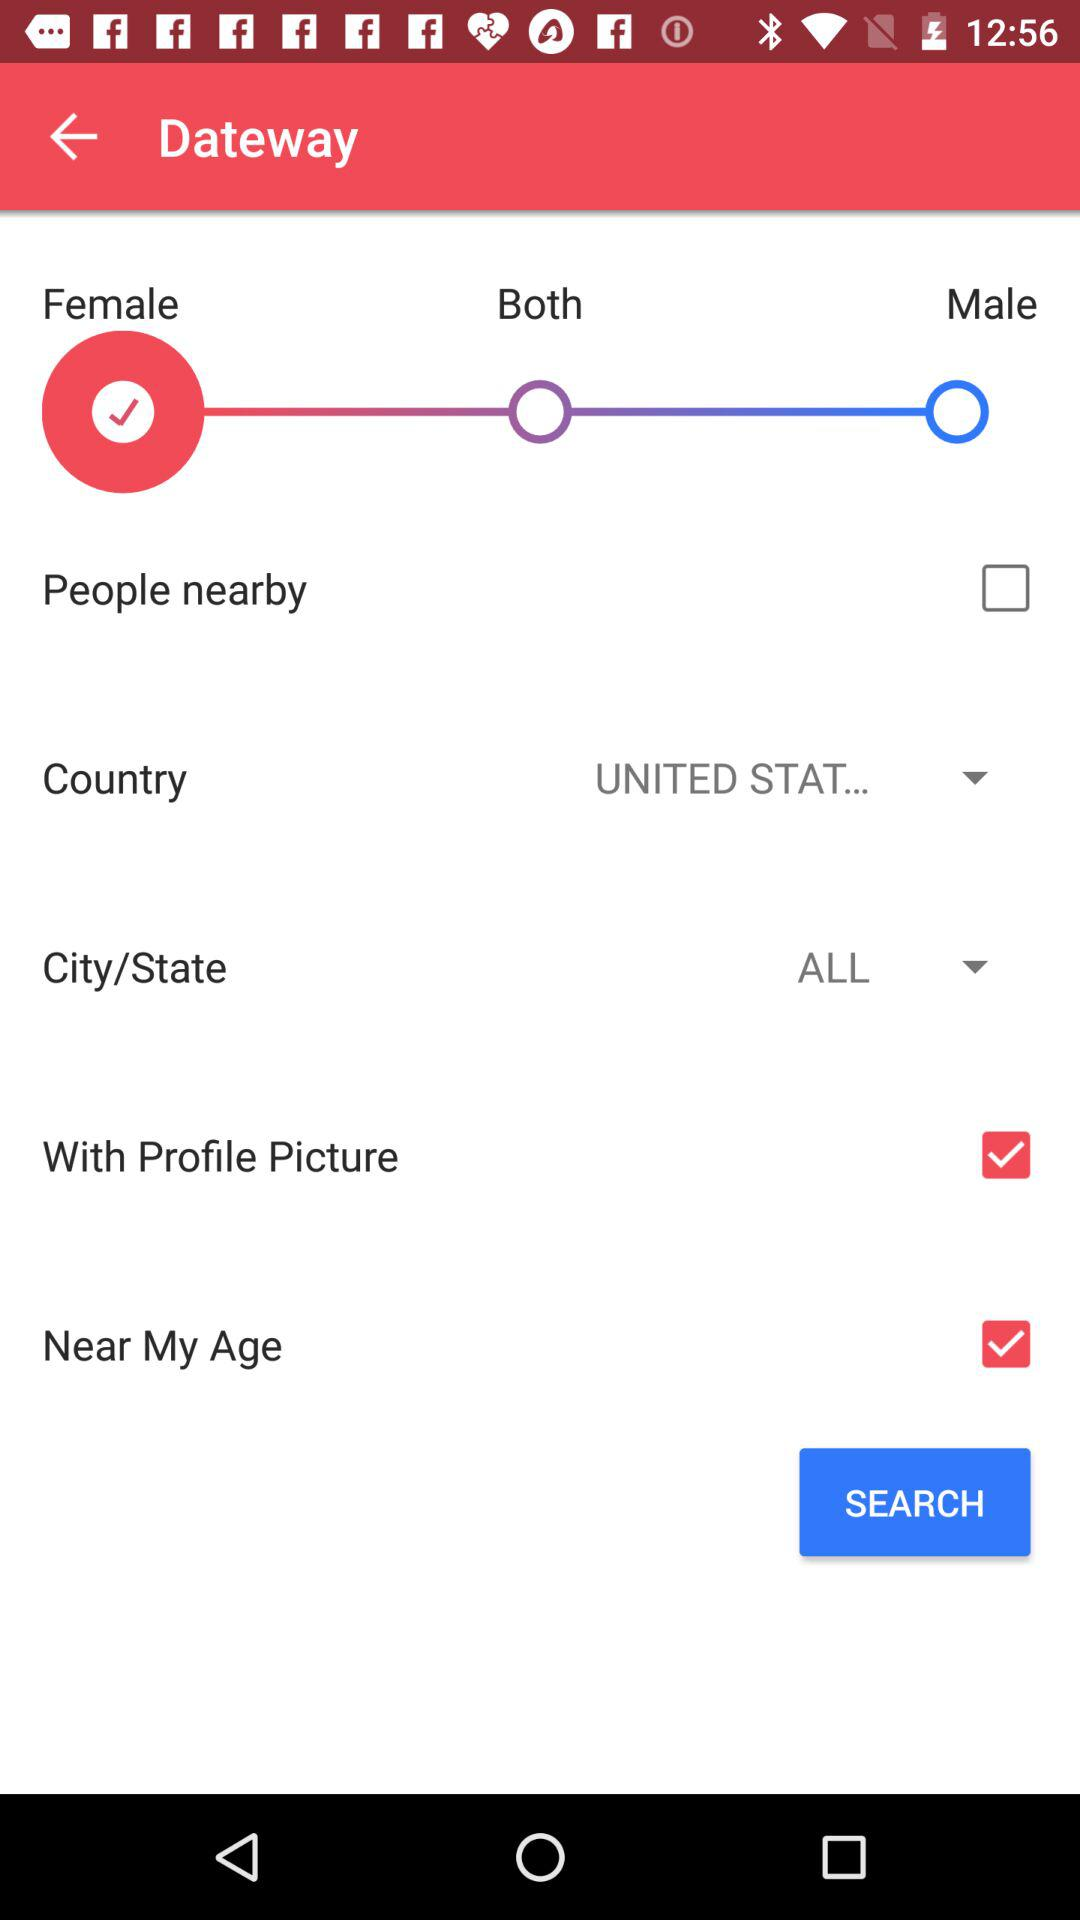What is the selected gender? The selected gender is female. 